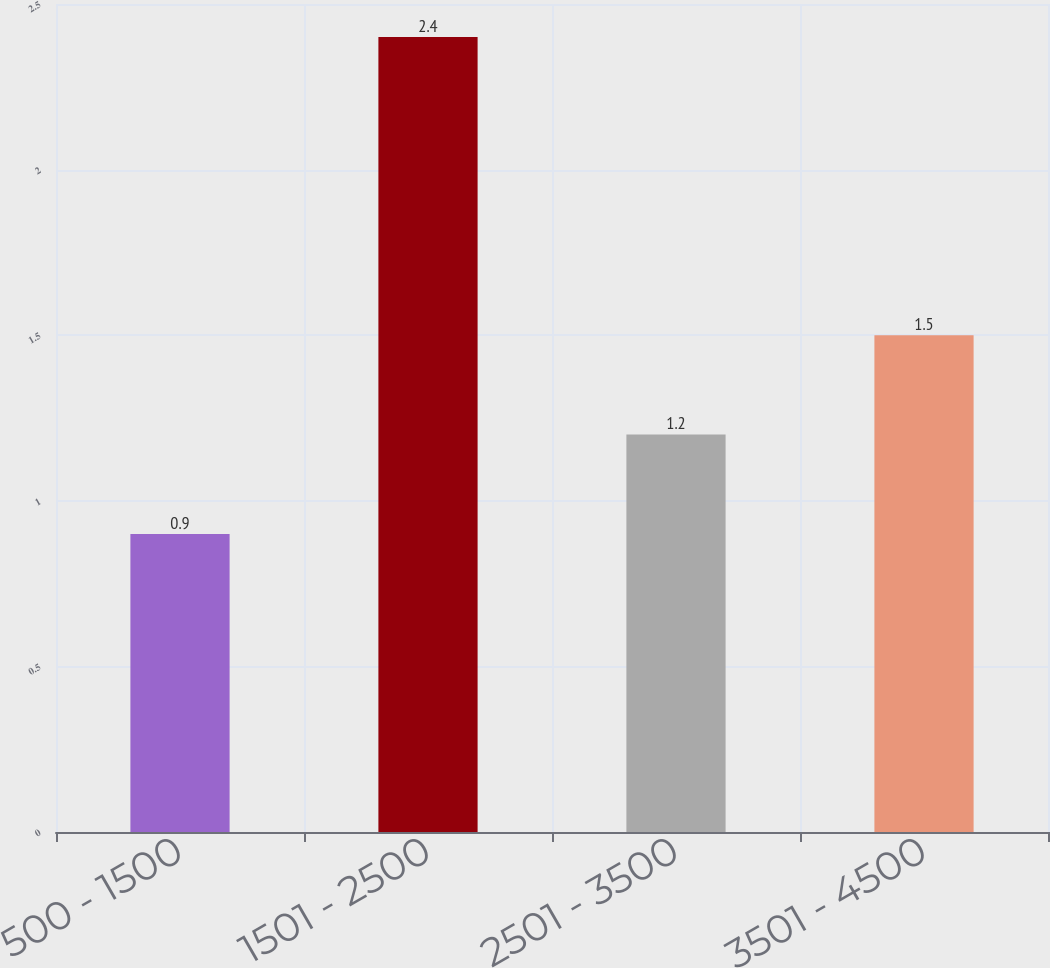Convert chart. <chart><loc_0><loc_0><loc_500><loc_500><bar_chart><fcel>500 - 1500<fcel>1501 - 2500<fcel>2501 - 3500<fcel>3501 - 4500<nl><fcel>0.9<fcel>2.4<fcel>1.2<fcel>1.5<nl></chart> 